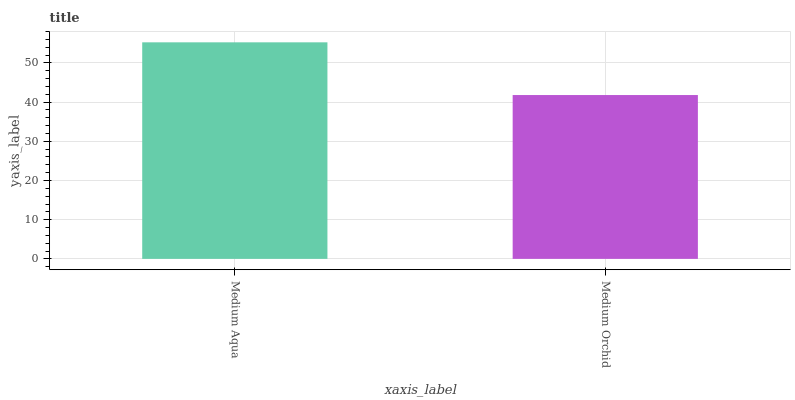Is Medium Orchid the minimum?
Answer yes or no. Yes. Is Medium Aqua the maximum?
Answer yes or no. Yes. Is Medium Orchid the maximum?
Answer yes or no. No. Is Medium Aqua greater than Medium Orchid?
Answer yes or no. Yes. Is Medium Orchid less than Medium Aqua?
Answer yes or no. Yes. Is Medium Orchid greater than Medium Aqua?
Answer yes or no. No. Is Medium Aqua less than Medium Orchid?
Answer yes or no. No. Is Medium Aqua the high median?
Answer yes or no. Yes. Is Medium Orchid the low median?
Answer yes or no. Yes. Is Medium Orchid the high median?
Answer yes or no. No. Is Medium Aqua the low median?
Answer yes or no. No. 